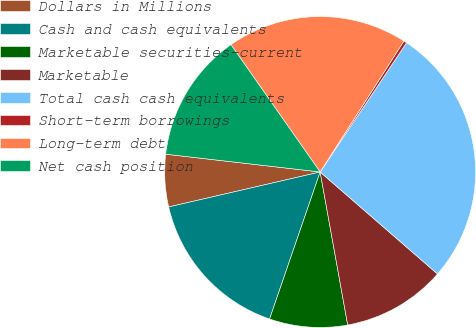<chart> <loc_0><loc_0><loc_500><loc_500><pie_chart><fcel>Dollars in Millions<fcel>Cash and cash equivalents<fcel>Marketable securities-current<fcel>Marketable<fcel>Total cash cash equivalents<fcel>Short-term borrowings<fcel>Long-term debt<fcel>Net cash position<nl><fcel>5.44%<fcel>16.12%<fcel>8.11%<fcel>10.78%<fcel>27.01%<fcel>0.32%<fcel>18.79%<fcel>13.45%<nl></chart> 